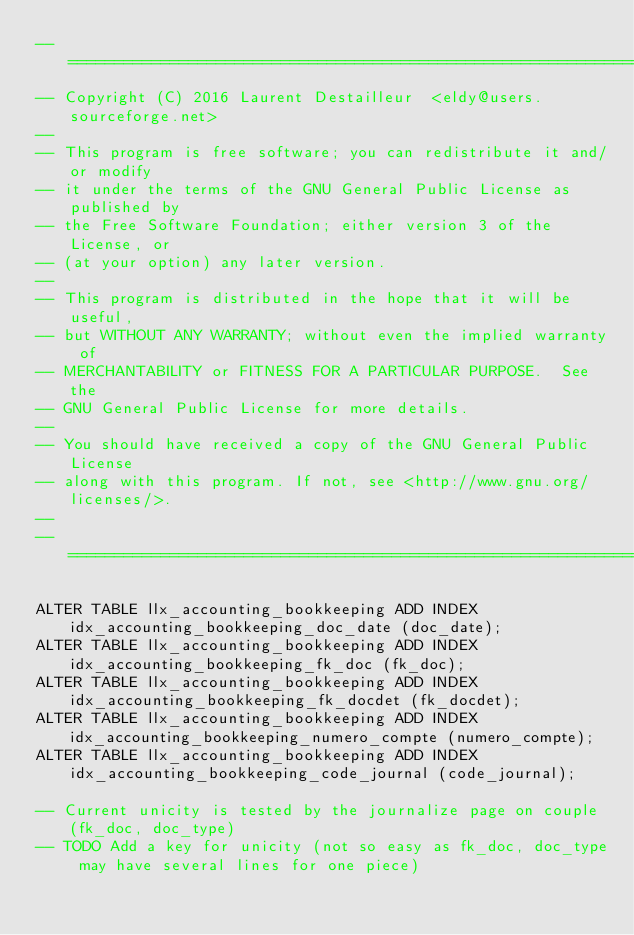Convert code to text. <code><loc_0><loc_0><loc_500><loc_500><_SQL_>-- ============================================================================
-- Copyright (C) 2016 Laurent Destailleur  <eldy@users.sourceforge.net>
--
-- This program is free software; you can redistribute it and/or modify
-- it under the terms of the GNU General Public License as published by
-- the Free Software Foundation; either version 3 of the License, or
-- (at your option) any later version.
--
-- This program is distributed in the hope that it will be useful,
-- but WITHOUT ANY WARRANTY; without even the implied warranty of
-- MERCHANTABILITY or FITNESS FOR A PARTICULAR PURPOSE.  See the
-- GNU General Public License for more details.
--
-- You should have received a copy of the GNU General Public License
-- along with this program. If not, see <http://www.gnu.org/licenses/>.
--
-- ============================================================================

ALTER TABLE llx_accounting_bookkeeping ADD INDEX idx_accounting_bookkeeping_doc_date (doc_date);
ALTER TABLE llx_accounting_bookkeeping ADD INDEX idx_accounting_bookkeeping_fk_doc (fk_doc);
ALTER TABLE llx_accounting_bookkeeping ADD INDEX idx_accounting_bookkeeping_fk_docdet (fk_docdet);
ALTER TABLE llx_accounting_bookkeeping ADD INDEX idx_accounting_bookkeeping_numero_compte (numero_compte);
ALTER TABLE llx_accounting_bookkeeping ADD INDEX idx_accounting_bookkeeping_code_journal (code_journal);

-- Current unicity is tested by the journalize page on couple (fk_doc, doc_type) 
-- TODO Add a key for unicity (not so easy as fk_doc, doc_type may have several lines for one piece)
</code> 